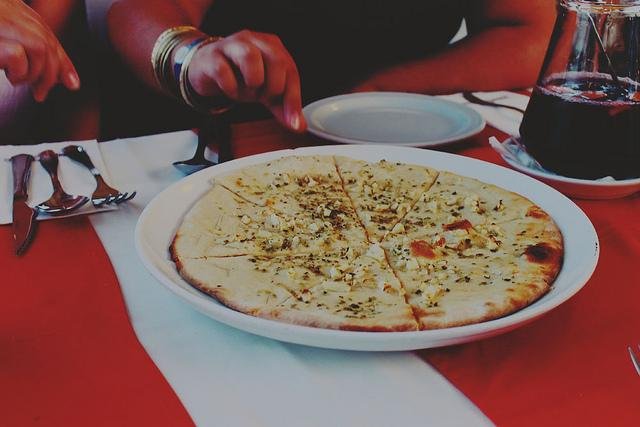What Leavening was used in this dish?

Choices:
A) yeast
B) none
C) rye
D) sour kraut yeast 